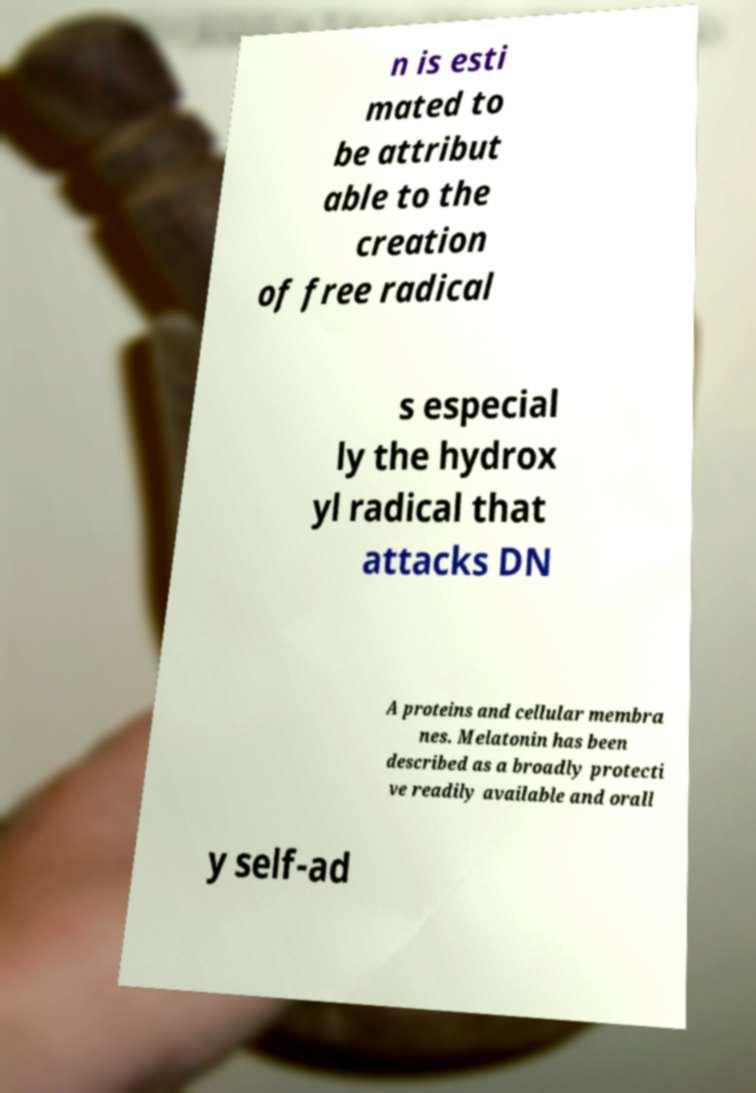Can you accurately transcribe the text from the provided image for me? n is esti mated to be attribut able to the creation of free radical s especial ly the hydrox yl radical that attacks DN A proteins and cellular membra nes. Melatonin has been described as a broadly protecti ve readily available and orall y self-ad 